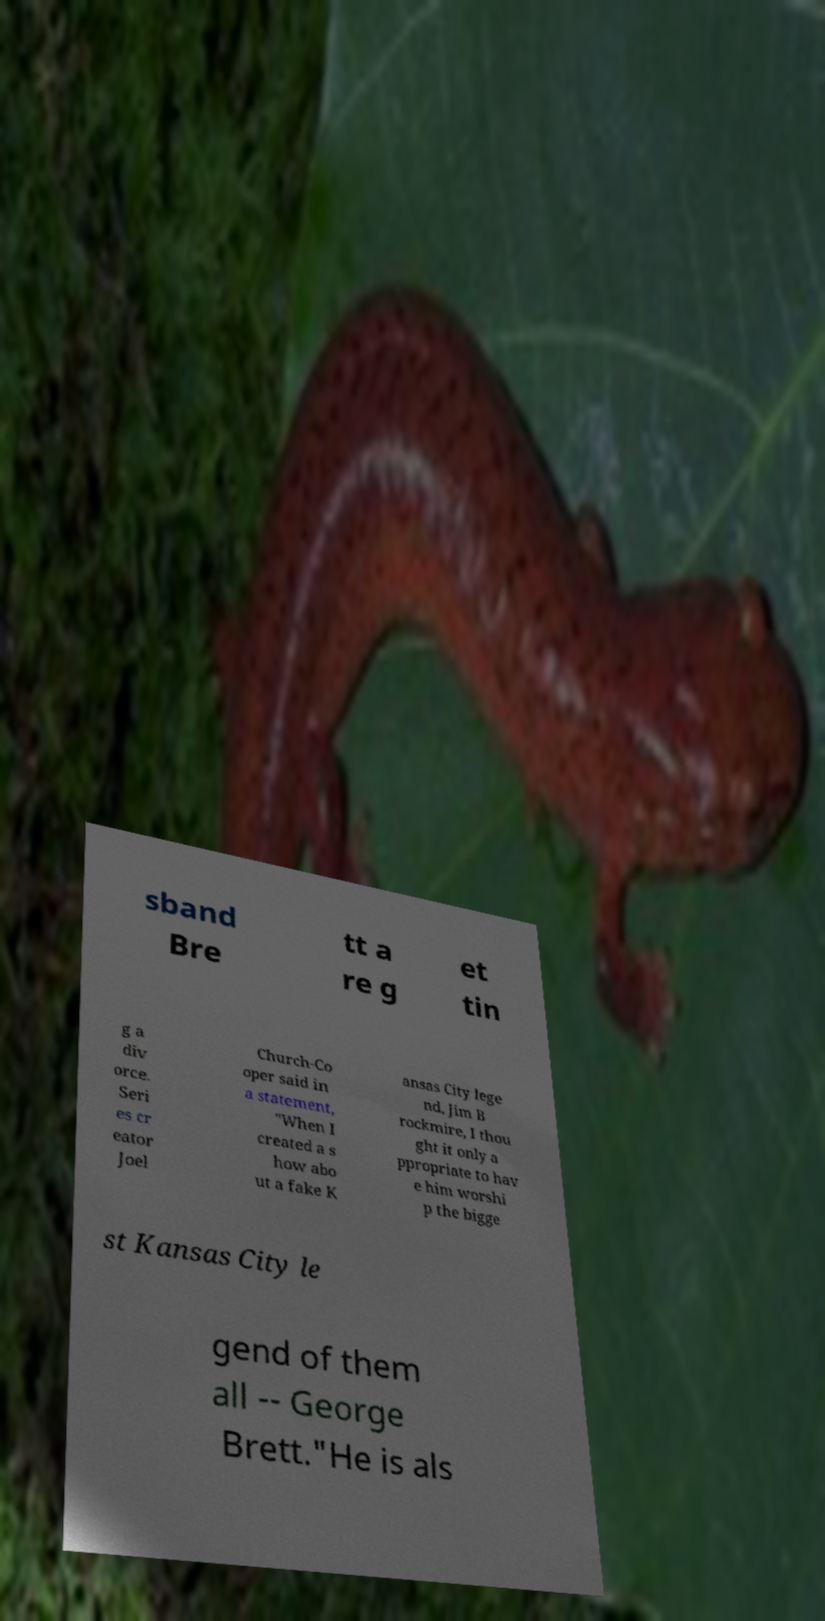Could you assist in decoding the text presented in this image and type it out clearly? sband Bre tt a re g et tin g a div orce. Seri es cr eator Joel Church-Co oper said in a statement, "When I created a s how abo ut a fake K ansas City lege nd, Jim B rockmire, I thou ght it only a ppropriate to hav e him worshi p the bigge st Kansas City le gend of them all -- George Brett."He is als 